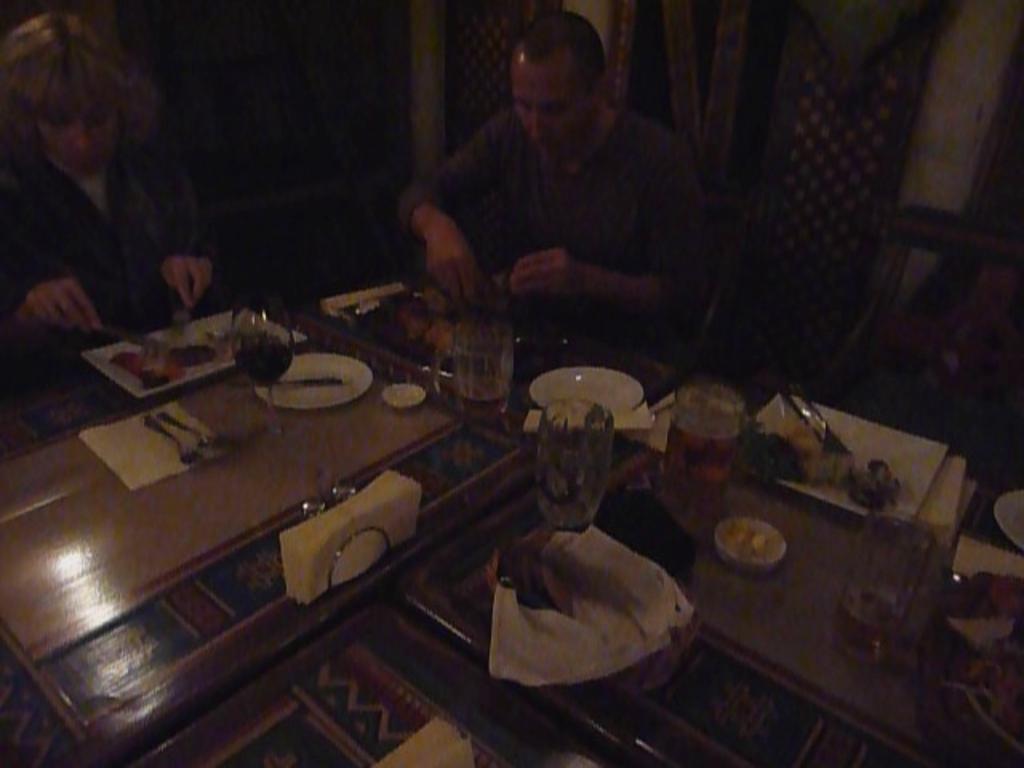Can you describe this image briefly? This picture is blur and dark and here we can see two persons sitting on chairs in front of a table and they are holding spoon and fork in their hands and on the table we can see tissue papers, spoons and forks,plate, jars, glasses 